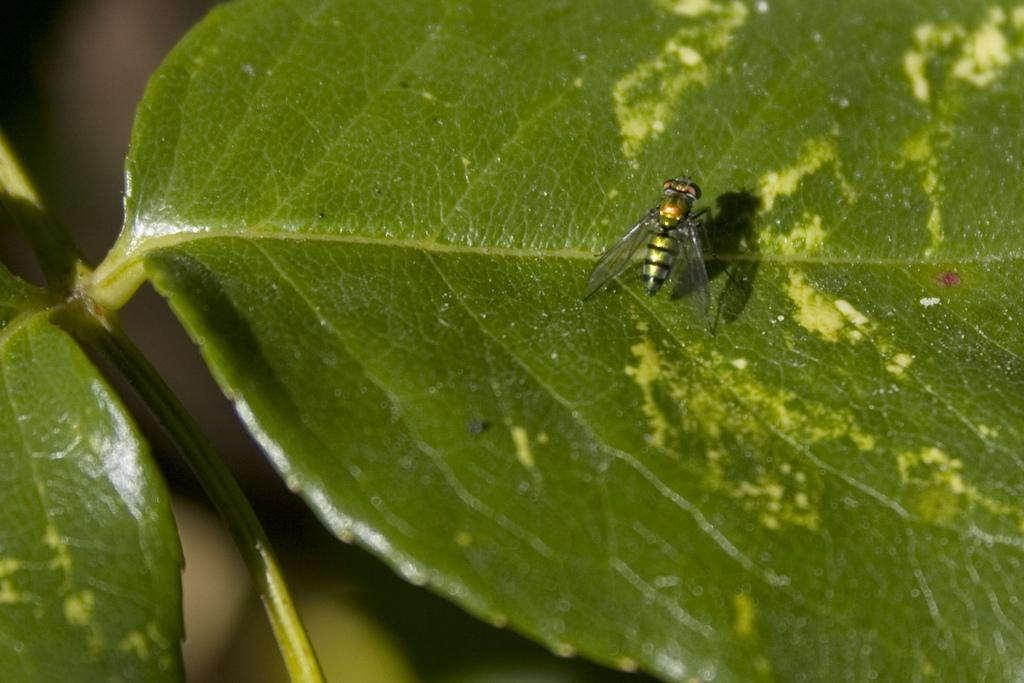What is the main subject of the image? The main subject of the image is a stem with leaves. Are there any additional elements on the leaves? Yes, there is an insect on one of the leaves. How would you describe the background of the image? The background of the image is blurred. How many spiders are crawling on the jail in the image? There is no jail or spiders present in the image. 